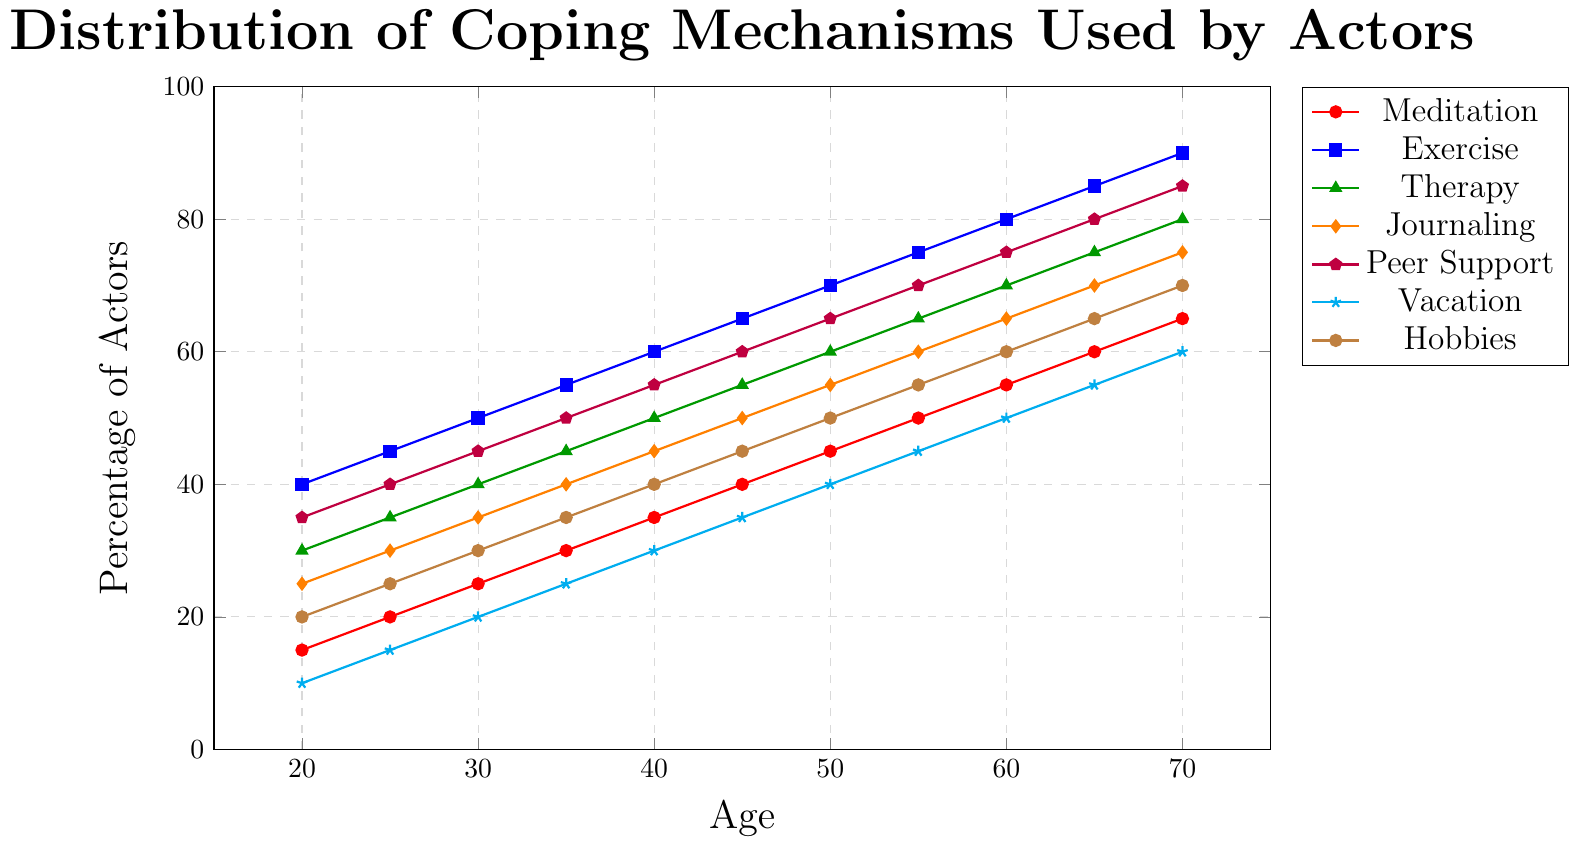What age group shows the highest percentage of actors using Peer Support? To find the highest percentage of Peer Support usage, look at the curve with the legend "Peer Support" (purple line) and identify the peak. The highest point is at age 70 with a value of 85%.
Answer: 70 How does the percentage of actors practicing Meditation at age 40 compare to those at age 60? Locate the points for Meditation (red line) at ages 40 and 60. At age 40, the value is 35%. At age 60, the value is 55%. Compare these values: 55% is higher than 35%.
Answer: Higher at age 60 What is the sum of the percentages for Exercise and Therapy at age 50? Locate the points for Exercise (blue line) and Therapy (green line) at age 50. Exercise is 70%, and Therapy is 60%. Sum these values: 70% + 60% = 130%.
Answer: 130% Which coping mechanism shows a steady increase across age groups from 20 to 70 without fluctuations? Identify the lines that increase linearly without any dips or plateaus. The line for "Hobbies" (brown) shows a steady increase.
Answer: Hobbies At age 30, which coping mechanism is used by the highest percentage of actors? Locate the points at age 30 for all coping mechanisms. Compare the vertical positions of the colored dots; the highest is Exercise (blue) at 50%.
Answer: Exercise By how much does the usage percentage of Therapy increase from age 25 to 55? Find the Therapy (green line) values at ages 25 and 55. At age 25, the value is 35%. At age 55, the value is 65%. Calculate the increase: 65% - 35% = 30%.
Answer: 30% How do the percentages of actors taking Vacations at ages 20 and 45 compare? Locate the points for Vacation (cyan line) at ages 20 and 45. At age 20, the value is 10%. At age 45, the value is 35%. Compare these values: 35% is higher than 10%.
Answer: Higher at age 45 What is the difference between the percentage of actors using Journaling and Peer Support at age 35? Find the values for Journaling (orange line) and Peer Support (purple line) at age 35. Journaling is 40%, and Peer Support is 50%. Calculate the difference: 50% - 40% = 10%.
Answer: 10% Which coping mechanism shows the smallest increase from age 20 to age 70? Compare the percentage changes from age 20 to age 70 for each coping mechanism. Meditation increases from 15% to 65% (50%), Exercise from 40% to 90% (50%), Therapy from 30% to 80% (50%), etc. Vacation (cyan line) increases the least from 10% to 60% (50%).
Answer: Vacation What is the average percentage of actors using Meditation over all age groups? Sum up the percentages for Meditation (red line) for all ages and divide by the number of age points: (15+20+25+30+35+40+45+50+55+60+65) = 440. The average is 440 / 11 = 40%.
Answer: 40% 